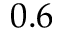<formula> <loc_0><loc_0><loc_500><loc_500>0 . 6</formula> 